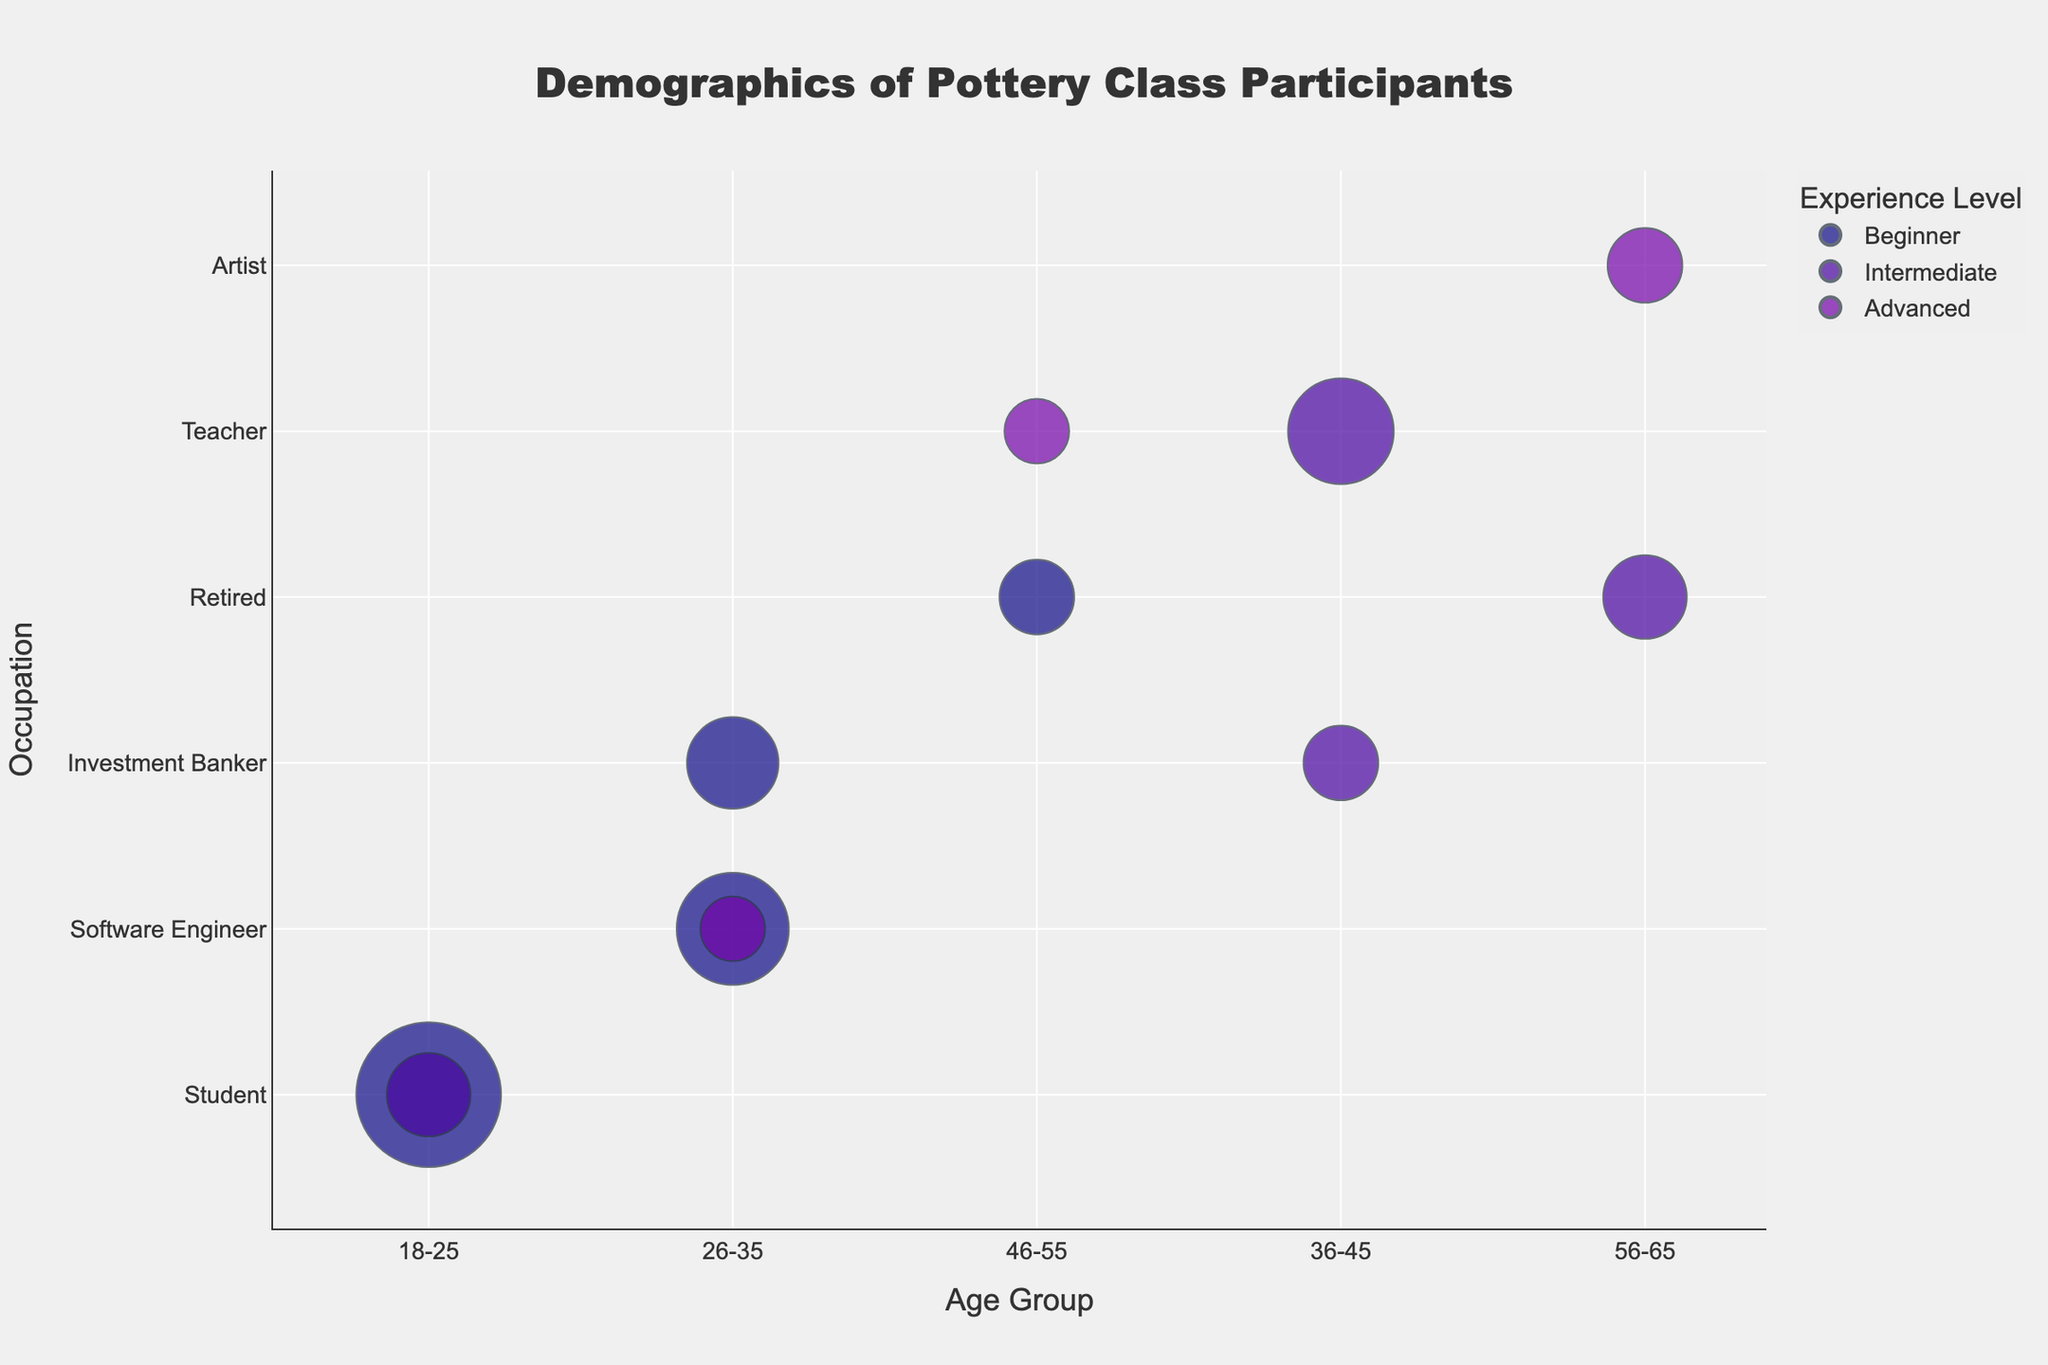1. What is the title of the chart? The title of the chart is usually found at the top of the figure. In this case, it mentions the overall theme of the demographics being studied.
Answer: Demographics of Pottery Class Participants 2. Which age group has the highest number of participants who are beginners? By looking at the sizes of the bubbles in different age groups and filtering those with the "Beginner" experience level, we can identify the largest bubble.
Answer: 18-25 3. How many intermediate participants are there in the "Teacher" occupation? Locate the "Teacher" occupation on the y-axis and then find the bubbles labeled "Intermediate" within that occupation. Sum the number of participants from those bubbles. There is one bubble with 40 participants.
Answer: 40 4. How does the number of participants in the "Software Engineer" occupation compare between beginners and advanced experience levels? Find the "Software Engineer" occupation on the y-axis and compare the sizes of the bubbles associated with "Beginner" and "Advanced". Beginner has 45 participants, Advanced has 15.
Answer: Beginners have more participants (45 vs 15) 5. Which occupation has the highest number of advanced participants in the 56-65 age group? Locate the 56-65 age group on the x-axis and look for the largest bubble with the "Advanced" experience level within that group.
Answer: Artist 6. What is the total number of participants aged 26-35? Sum the number of participants from all bubbles within the 26-35 age group. The bubbles are: Software Engineer (Beginner: 45, Advanced: 15) and Investment Banker (Beginner: 30). The total is 45 + 15 + 30.
Answer: 90 7. Compare the distribution of intermediate participants between the 18-25 and 36-45 age groups. Identify the intermediate bubbles within the 18-25 age group (Student: 25) and the 36-45 age group (Teacher: 40, Investment Banker: 20), then compare their sizes.
Answer: 18-25 has fewer participants (25 vs 60) 8. How does the number of retired beginner participants compare between the 46-55 and 56-65 age groups? Find the bubbles for retired participants in the specified age groups and compare their sizes. For 46-55, there are 20 participants, and for 56-65, there are 0 retired beginners.
Answer: 46-55 has more (20 vs 0) 9. In which occupation within the 26-35 age group is the distribution of experience levels more diverse? Look at the 26-35 age group and examine the number of different experience levels for each occupation. Software Engineers have both Beginner (45) and Advanced (15), while Investment Bankers have only Beginner (30).
Answer: Software Engineer 